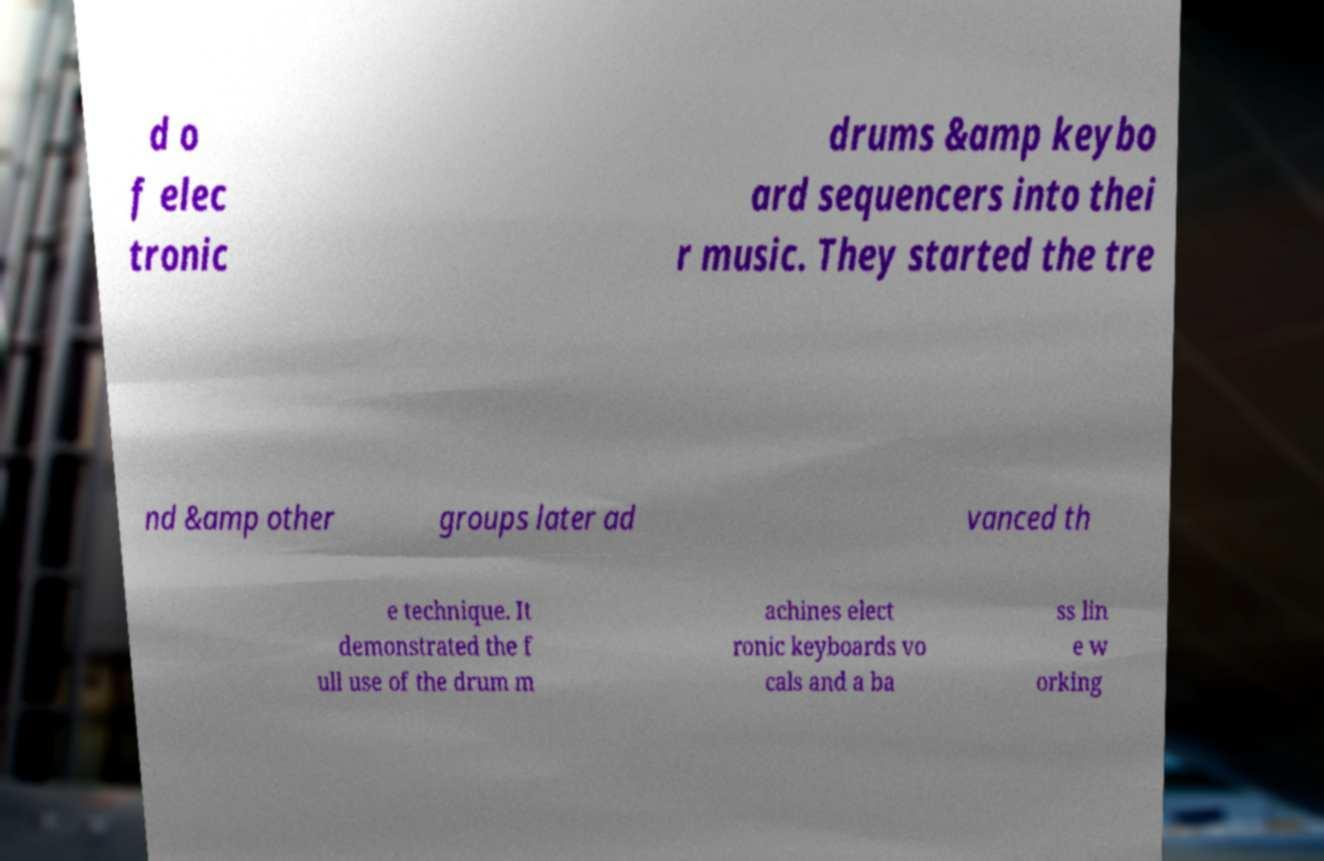Could you assist in decoding the text presented in this image and type it out clearly? d o f elec tronic drums &amp keybo ard sequencers into thei r music. They started the tre nd &amp other groups later ad vanced th e technique. It demonstrated the f ull use of the drum m achines elect ronic keyboards vo cals and a ba ss lin e w orking 